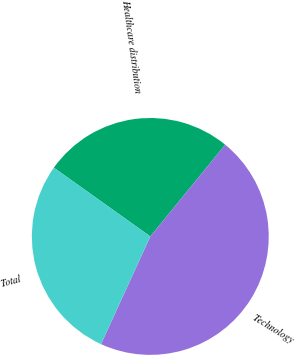Convert chart. <chart><loc_0><loc_0><loc_500><loc_500><pie_chart><fcel>Healthcare distribution<fcel>Technology<fcel>Total<nl><fcel>26.04%<fcel>45.93%<fcel>28.03%<nl></chart> 